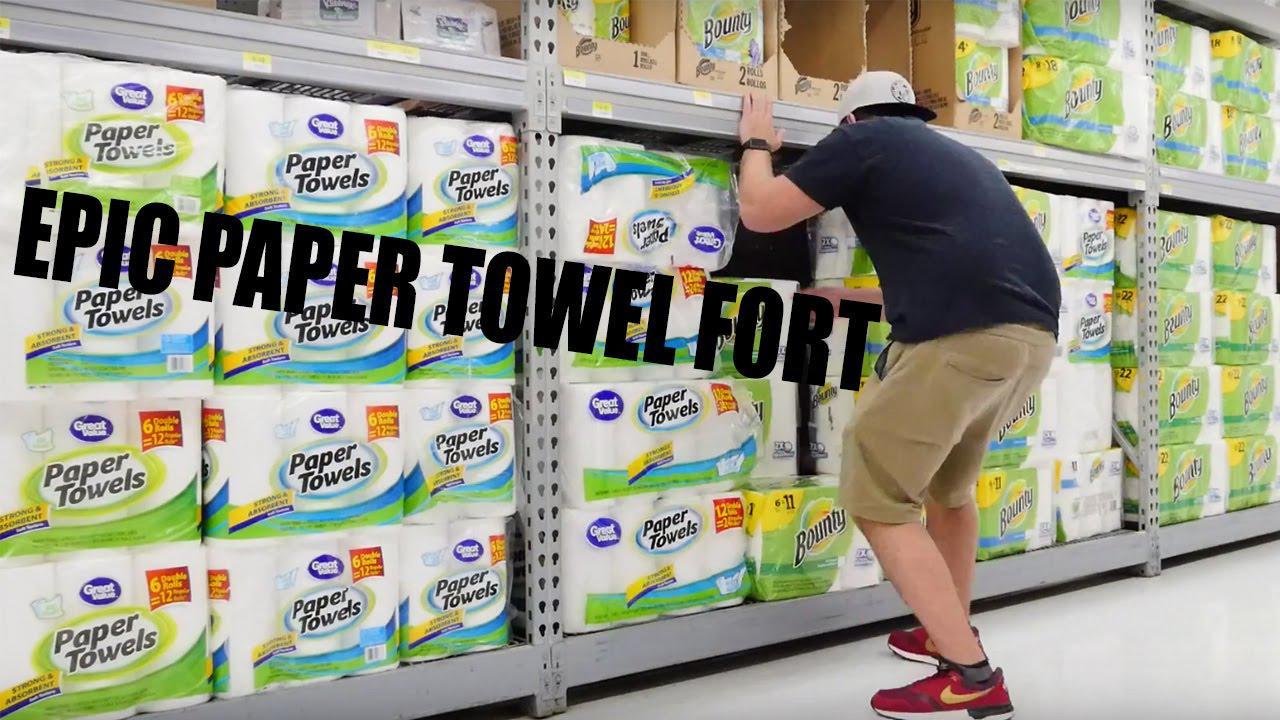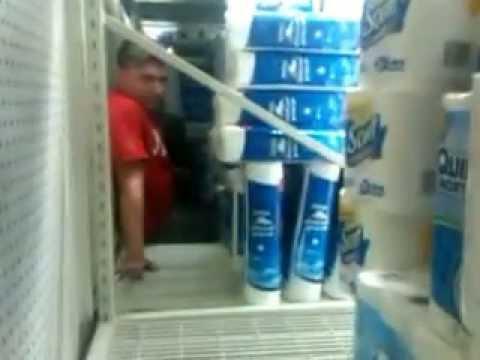The first image is the image on the left, the second image is the image on the right. Considering the images on both sides, is "A single person sits nears piles of paper goods in the image on the right." valid? Answer yes or no. Yes. 